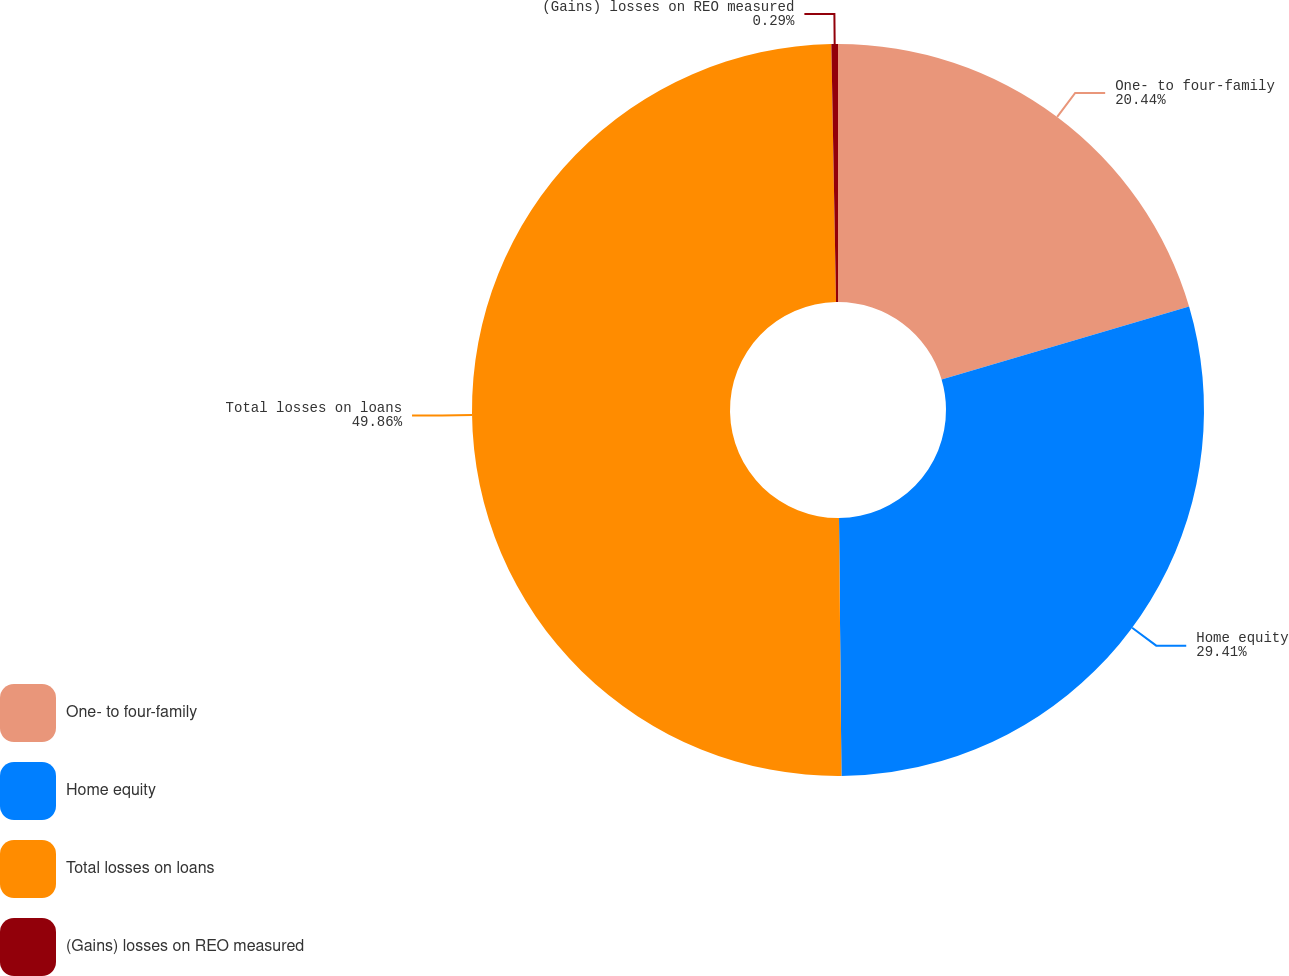<chart> <loc_0><loc_0><loc_500><loc_500><pie_chart><fcel>One- to four-family<fcel>Home equity<fcel>Total losses on loans<fcel>(Gains) losses on REO measured<nl><fcel>20.44%<fcel>29.41%<fcel>49.86%<fcel>0.29%<nl></chart> 